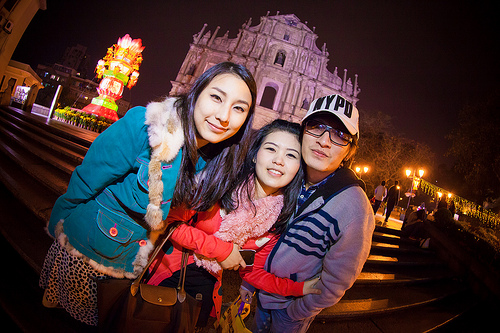<image>
Is there a girl on the man? Yes. Looking at the image, I can see the girl is positioned on top of the man, with the man providing support. Is the women next to the building? No. The women is not positioned next to the building. They are located in different areas of the scene. 